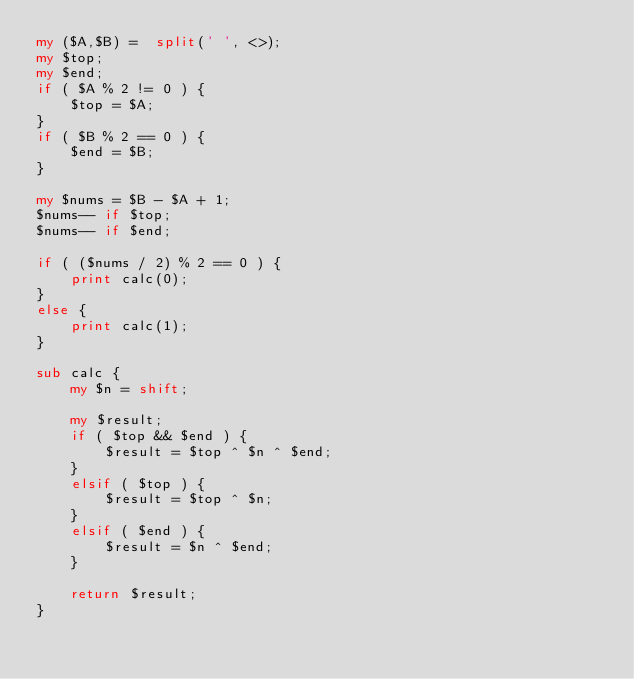Convert code to text. <code><loc_0><loc_0><loc_500><loc_500><_Perl_>my ($A,$B) =  split(' ', <>);
my $top;
my $end;
if ( $A % 2 != 0 ) {
    $top = $A;
}
if ( $B % 2 == 0 ) {
    $end = $B;
}

my $nums = $B - $A + 1;
$nums-- if $top;
$nums-- if $end;

if ( ($nums / 2) % 2 == 0 ) {
    print calc(0);
}
else {
    print calc(1);
}

sub calc {
    my $n = shift;

    my $result;
    if ( $top && $end ) {
        $result = $top ^ $n ^ $end;
    }
    elsif ( $top ) {
        $result = $top ^ $n;
    }
    elsif ( $end ) {
        $result = $n ^ $end;
    }

    return $result;
}</code> 